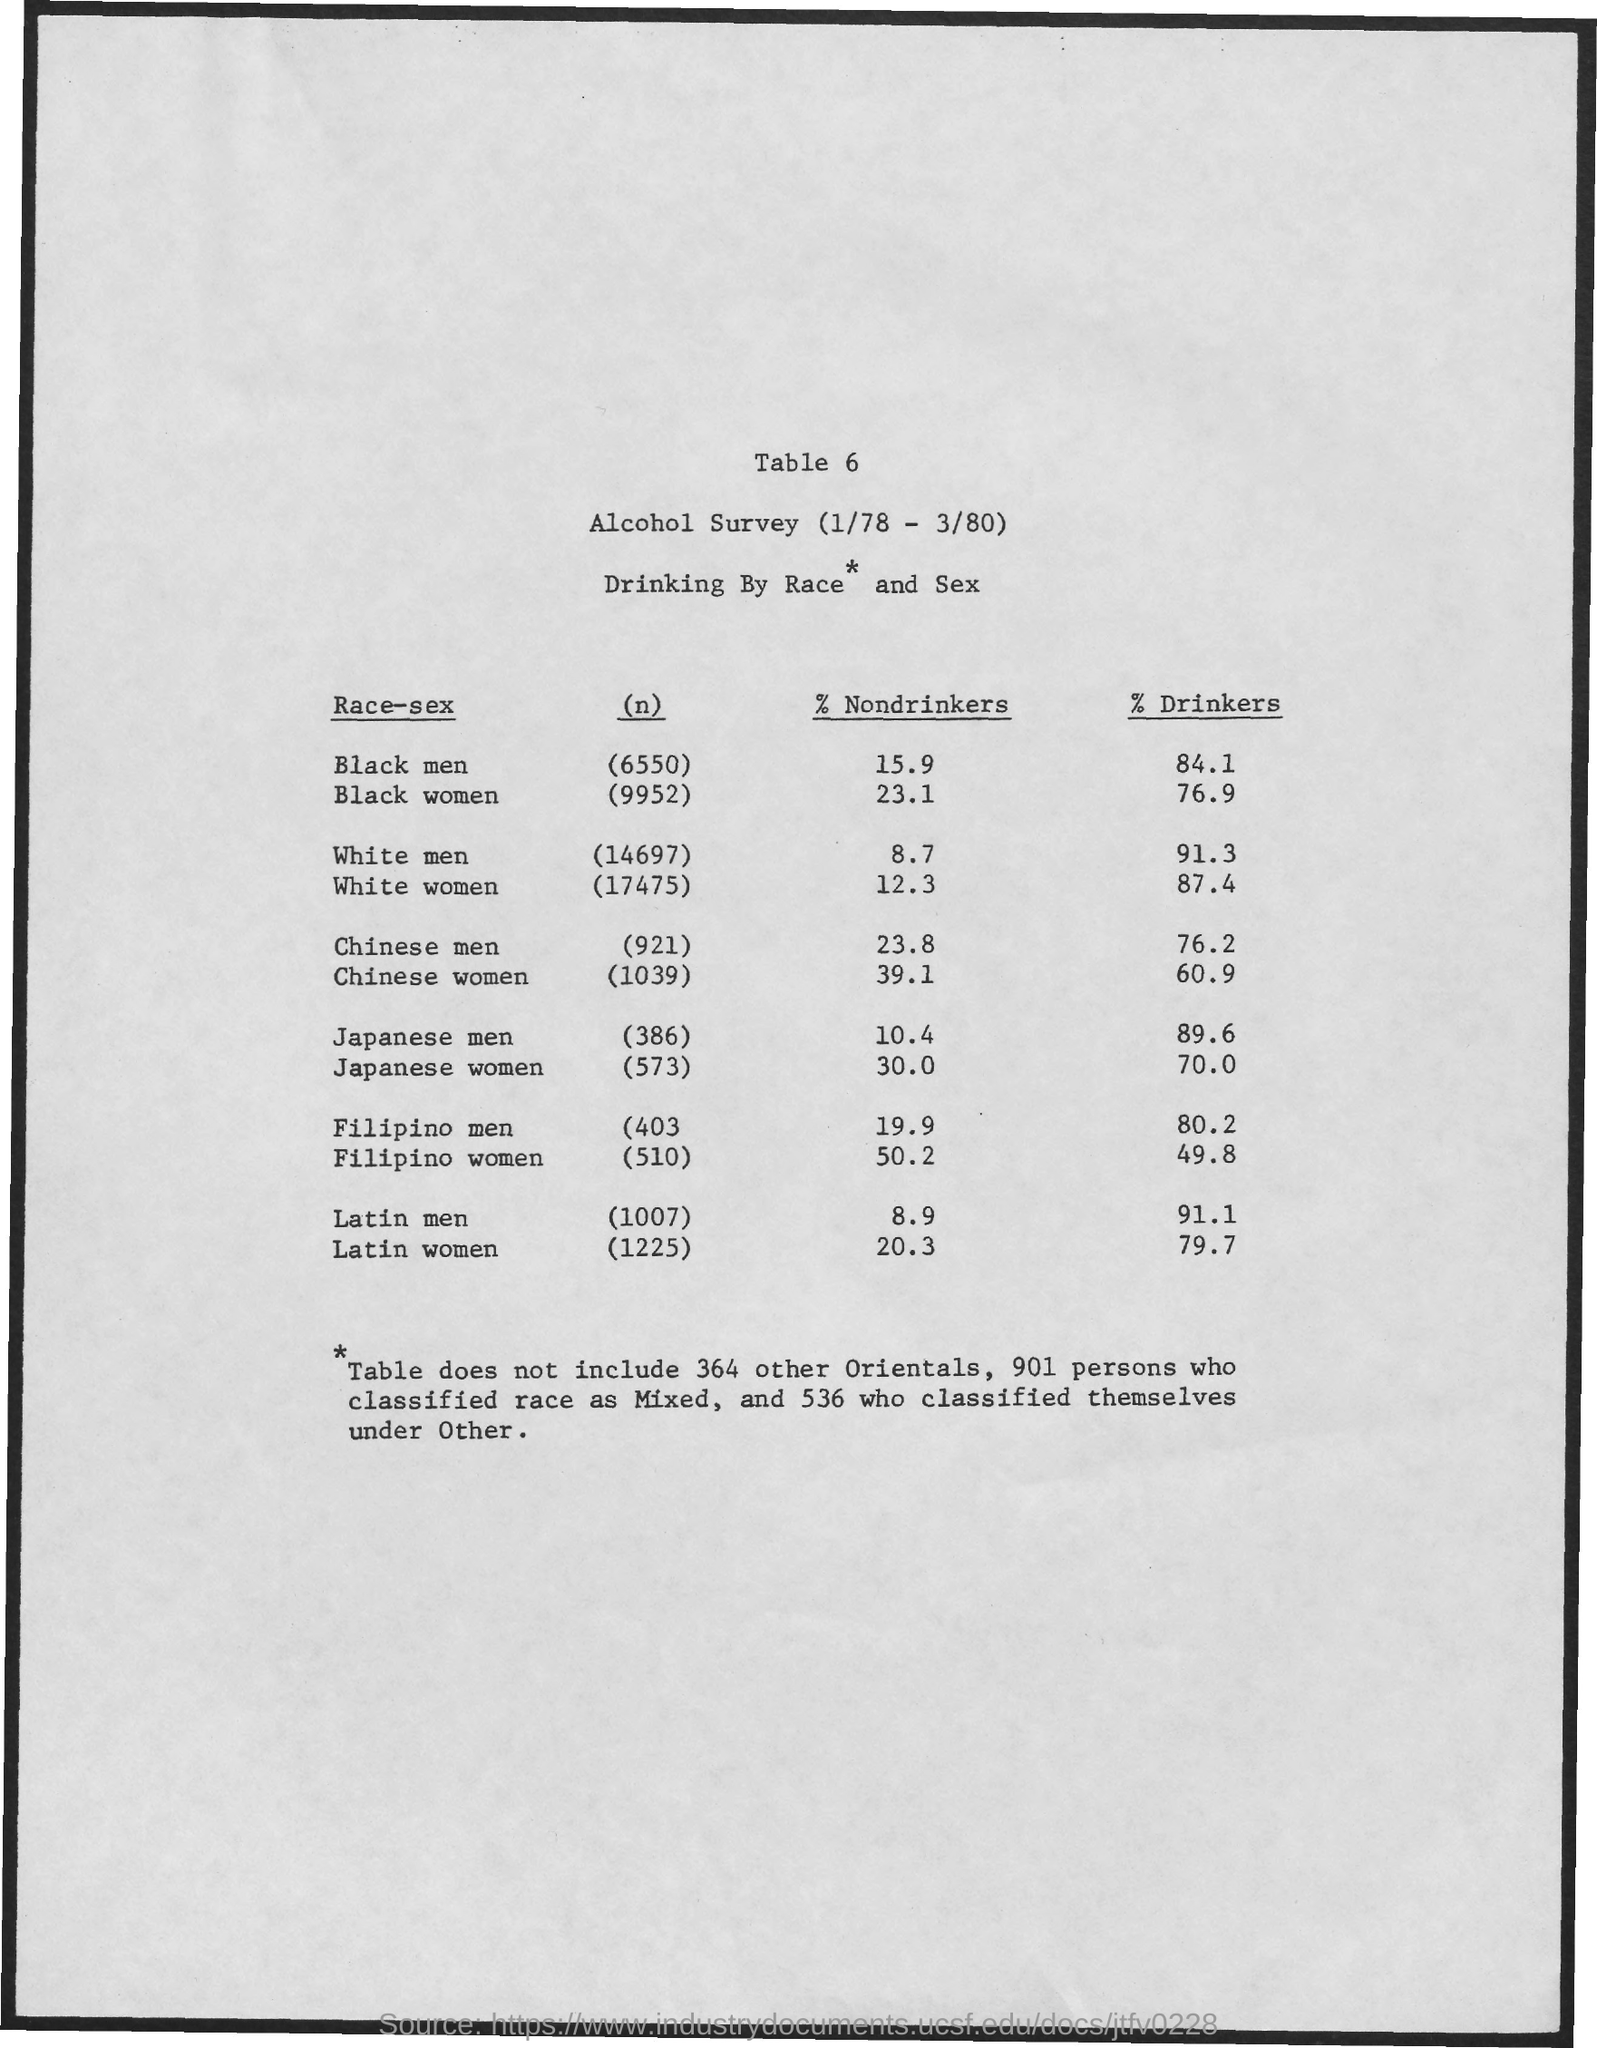Mention a couple of crucial points in this snapshot. According to the data, Filipino women have the highest percentage of nondrinkers among all races and genders. According to a recent study, 87.4% of white women reported consuming alcohol. A new study reveals that the percentage of nondrinkers is lowest among white men. There are approximately 6,550 Black men in the United States. The study found that 15.9% of black men do not consume alcohol. 